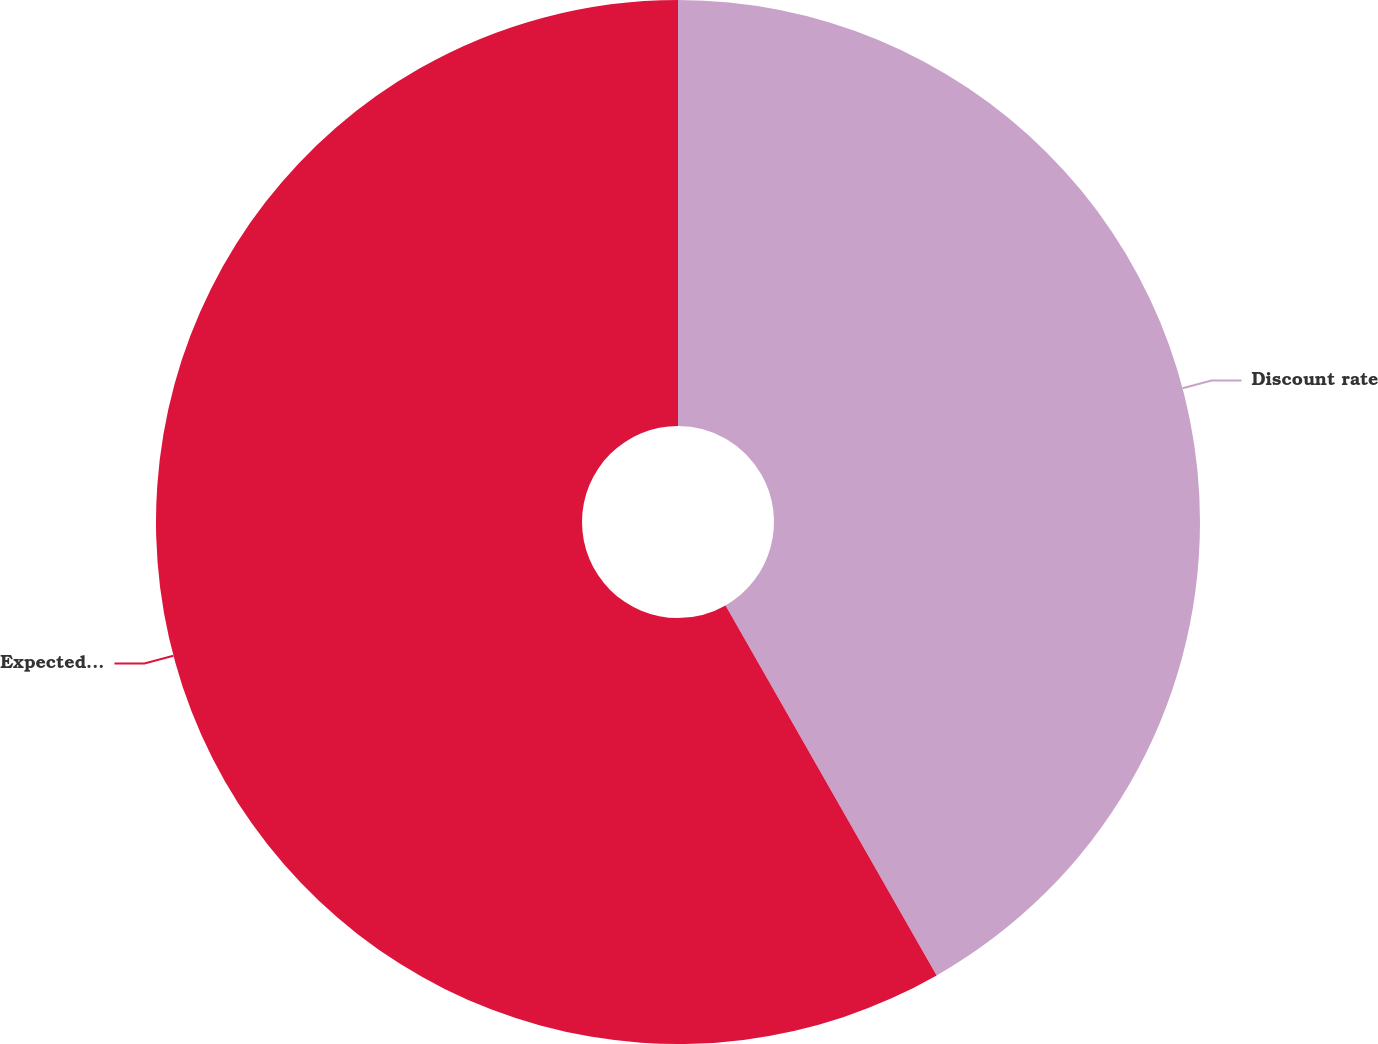Convert chart to OTSL. <chart><loc_0><loc_0><loc_500><loc_500><pie_chart><fcel>Discount rate<fcel>Expected return on plan assets<nl><fcel>41.75%<fcel>58.25%<nl></chart> 